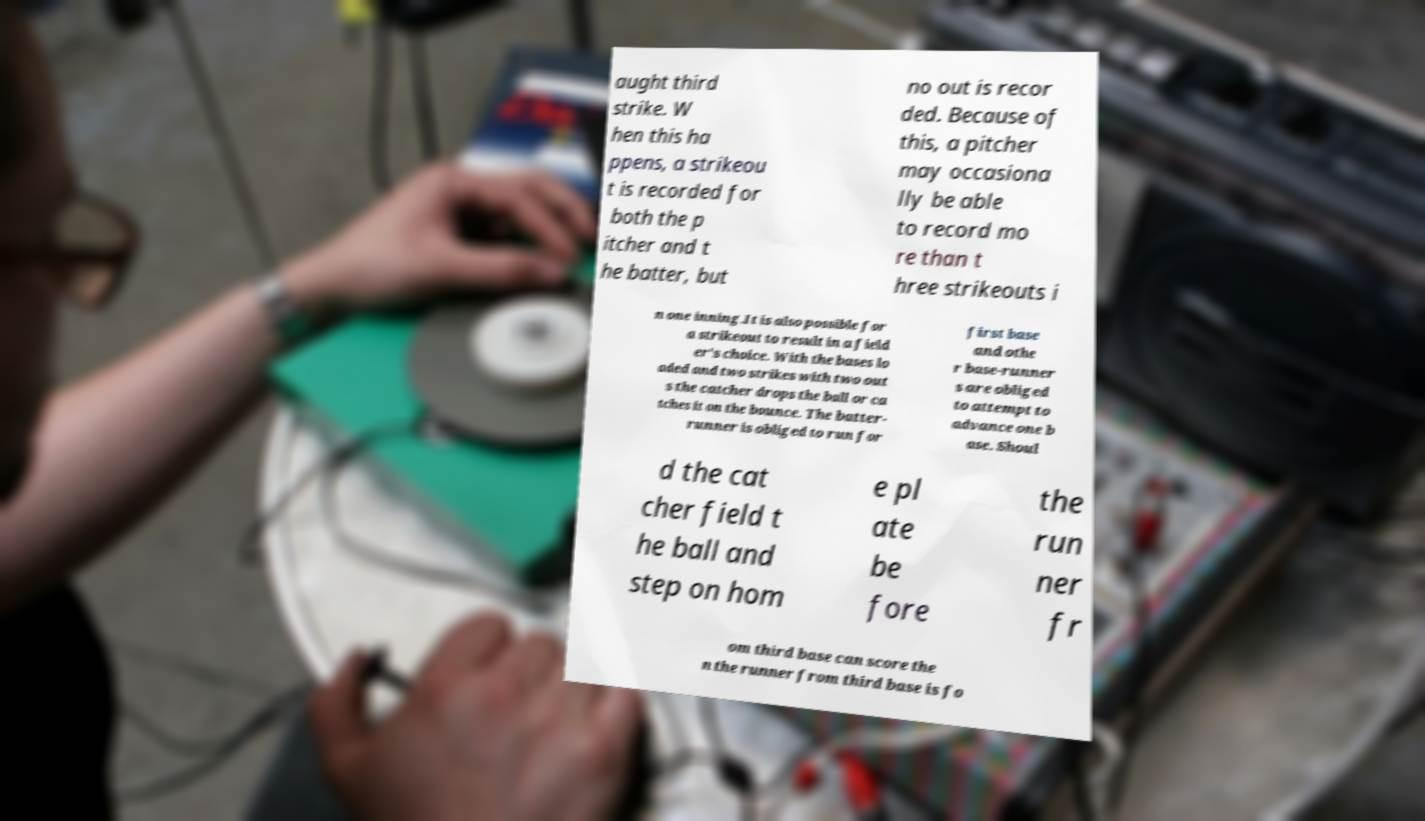Can you accurately transcribe the text from the provided image for me? aught third strike. W hen this ha ppens, a strikeou t is recorded for both the p itcher and t he batter, but no out is recor ded. Because of this, a pitcher may occasiona lly be able to record mo re than t hree strikeouts i n one inning.It is also possible for a strikeout to result in a field er's choice. With the bases lo aded and two strikes with two out s the catcher drops the ball or ca tches it on the bounce. The batter- runner is obliged to run for first base and othe r base-runner s are obliged to attempt to advance one b ase. Shoul d the cat cher field t he ball and step on hom e pl ate be fore the run ner fr om third base can score the n the runner from third base is fo 